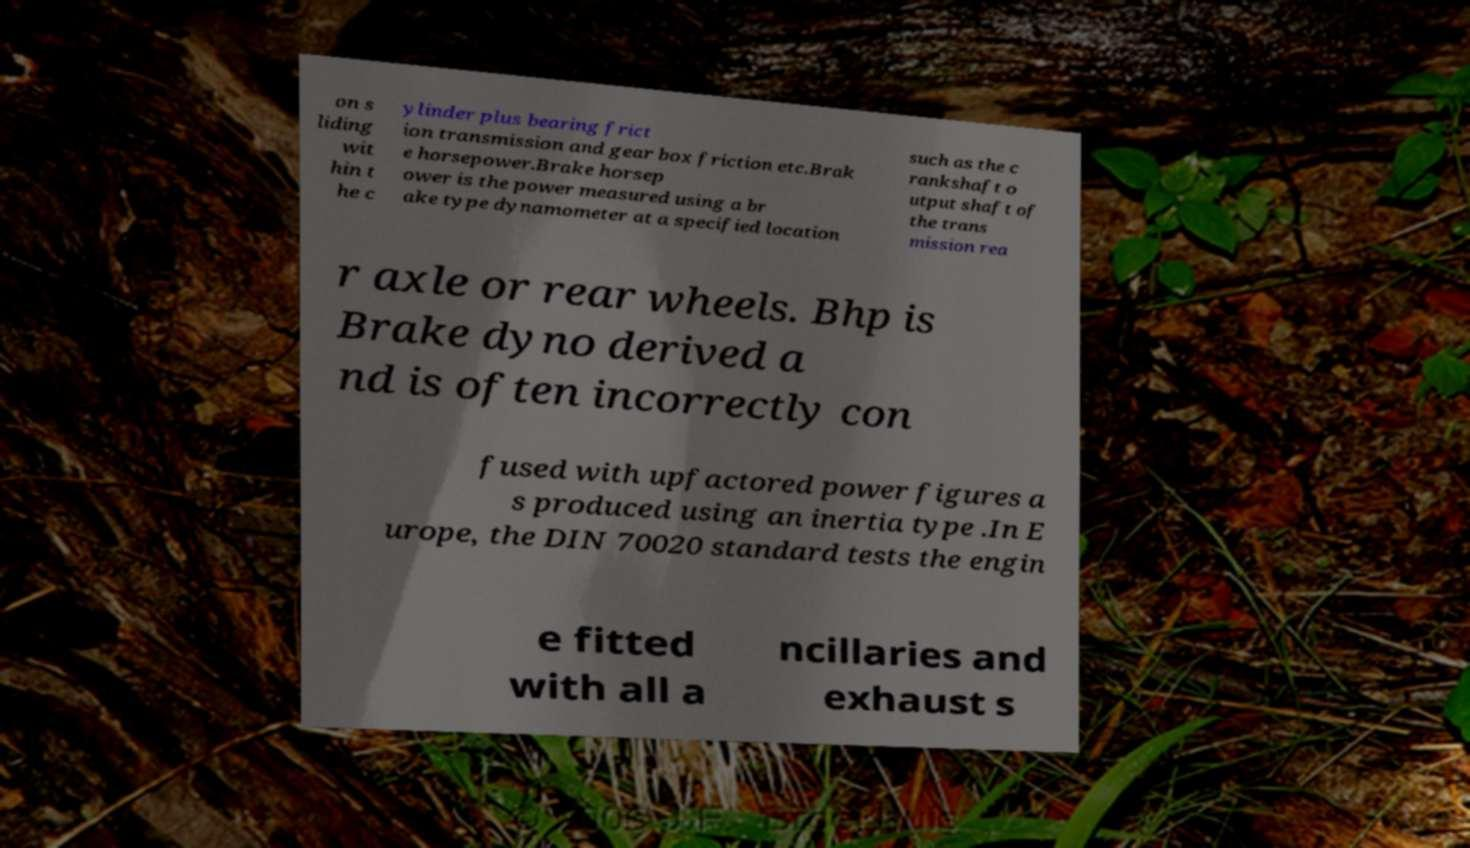Can you read and provide the text displayed in the image?This photo seems to have some interesting text. Can you extract and type it out for me? on s liding wit hin t he c ylinder plus bearing frict ion transmission and gear box friction etc.Brak e horsepower.Brake horsep ower is the power measured using a br ake type dynamometer at a specified location such as the c rankshaft o utput shaft of the trans mission rea r axle or rear wheels. Bhp is Brake dyno derived a nd is often incorrectly con fused with upfactored power figures a s produced using an inertia type .In E urope, the DIN 70020 standard tests the engin e fitted with all a ncillaries and exhaust s 